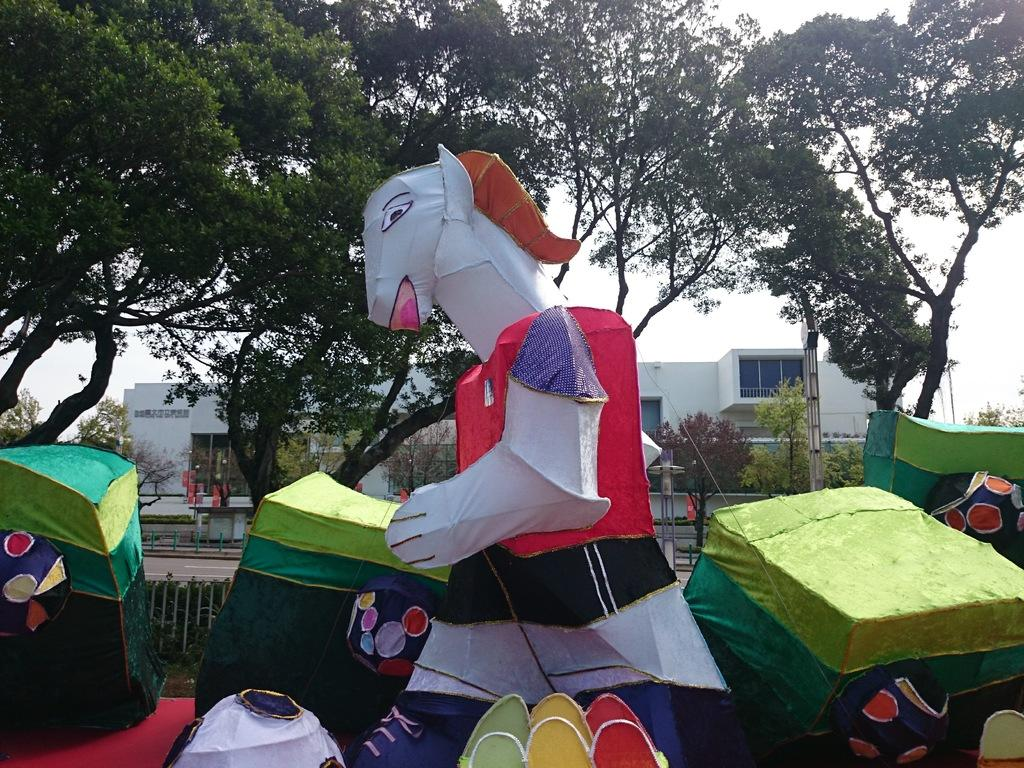What type of temporary shelters can be seen in the image? There are tents in the image. What large object is present in the image? There is a huge toy costume in the image. What type of natural vegetation is visible in the image? There are trees visible in the image. What type of structure can be seen in the background of the image? There is a building in the background of the image. Where are the kittens playing with a straw in the image? There are no kittens or straw present in the image. What type of decorative container is visible in the image? There is no vase present in the image. 